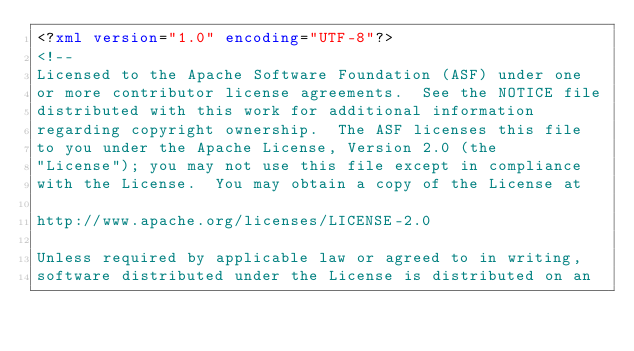Convert code to text. <code><loc_0><loc_0><loc_500><loc_500><_XML_><?xml version="1.0" encoding="UTF-8"?>
<!--
Licensed to the Apache Software Foundation (ASF) under one
or more contributor license agreements.  See the NOTICE file
distributed with this work for additional information
regarding copyright ownership.  The ASF licenses this file
to you under the Apache License, Version 2.0 (the
"License"); you may not use this file except in compliance
with the License.  You may obtain a copy of the License at

http://www.apache.org/licenses/LICENSE-2.0

Unless required by applicable law or agreed to in writing,
software distributed under the License is distributed on an</code> 